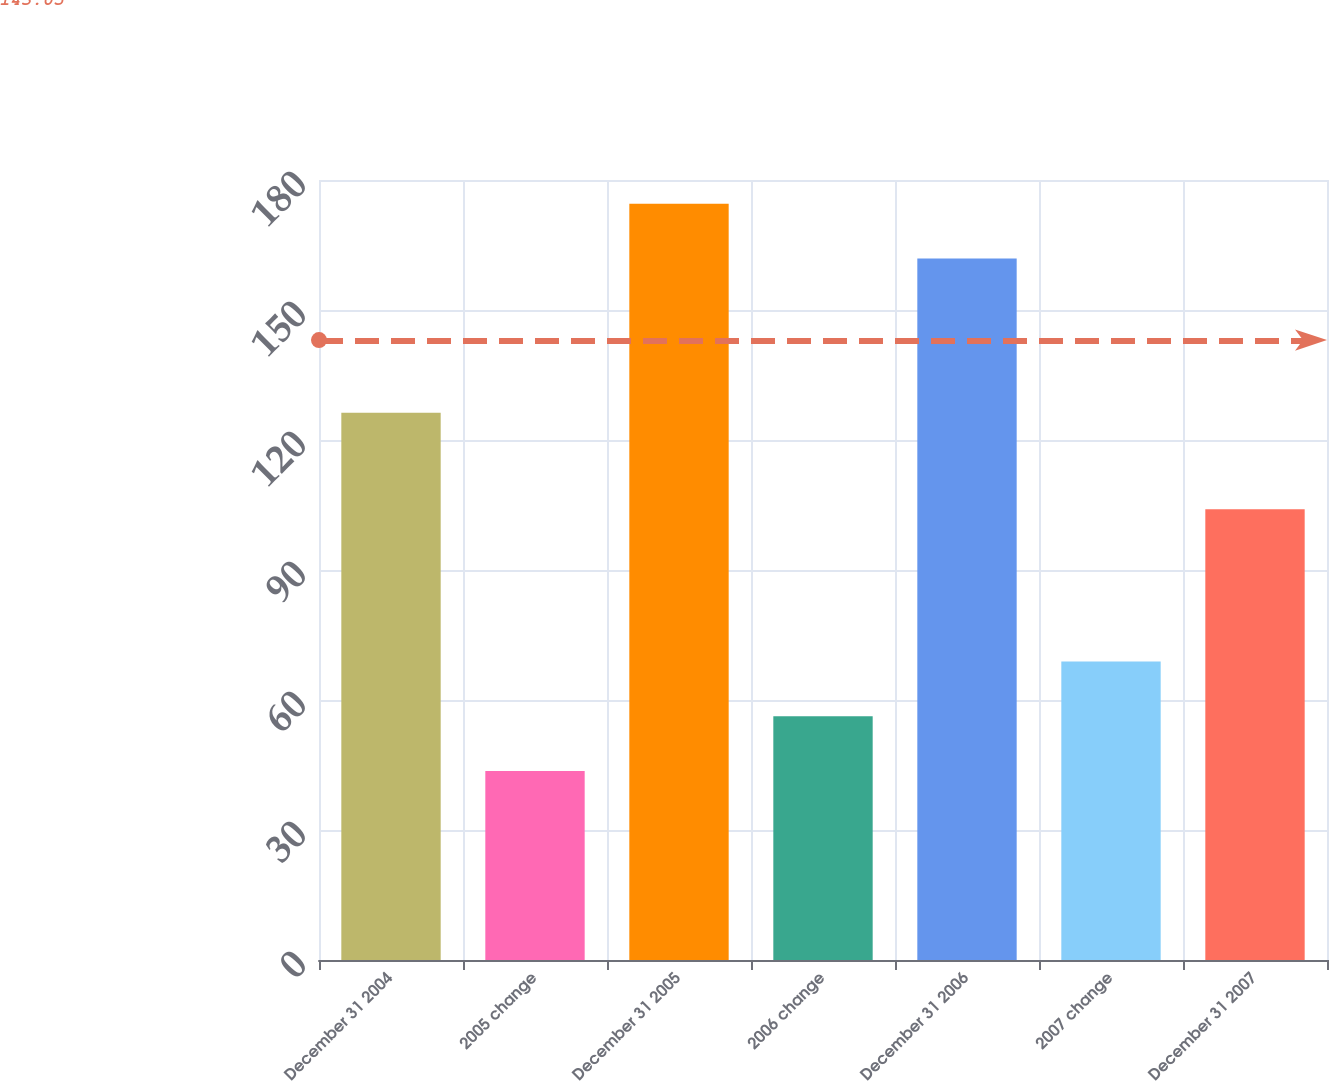Convert chart to OTSL. <chart><loc_0><loc_0><loc_500><loc_500><bar_chart><fcel>December 31 2004<fcel>2005 change<fcel>December 31 2005<fcel>2006 change<fcel>December 31 2006<fcel>2007 change<fcel>December 31 2007<nl><fcel>126.3<fcel>43.6<fcel>174.53<fcel>56.23<fcel>161.9<fcel>68.86<fcel>104<nl></chart> 